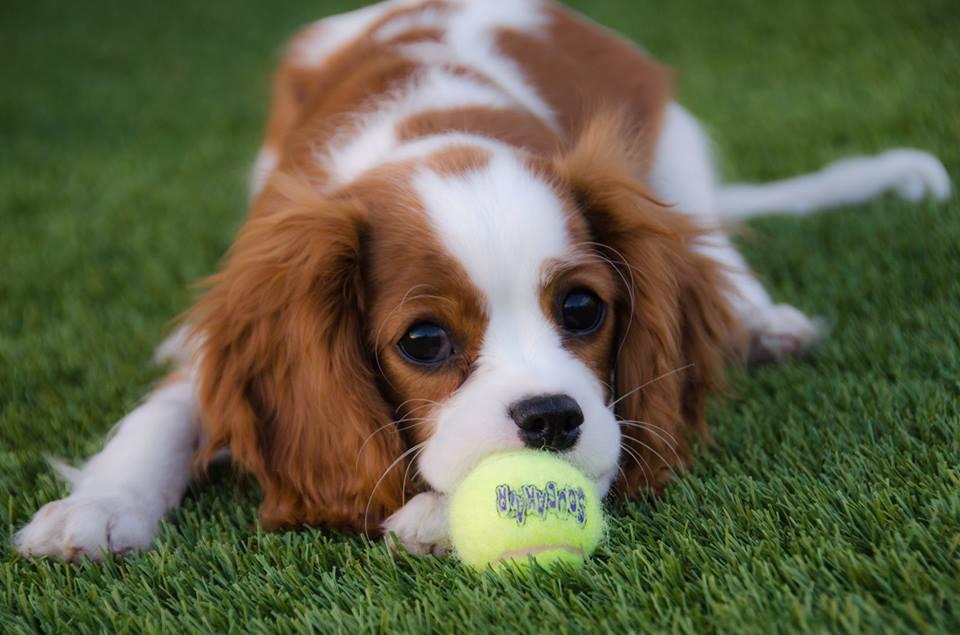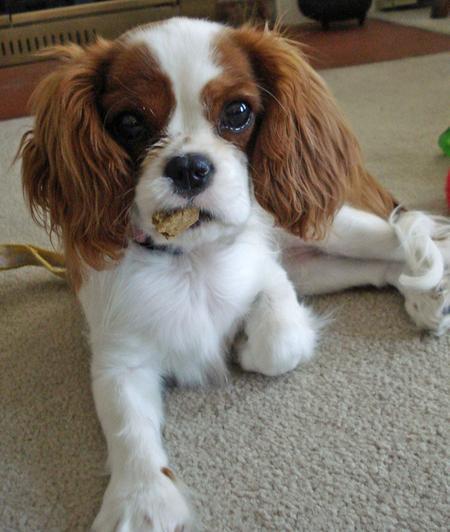The first image is the image on the left, the second image is the image on the right. Examine the images to the left and right. Is the description "There are two dogs looking directly at the camera." accurate? Answer yes or no. Yes. The first image is the image on the left, the second image is the image on the right. For the images displayed, is the sentence "An image shows a brown and white spaniel puppy on a varnished wood floor." factually correct? Answer yes or no. No. 